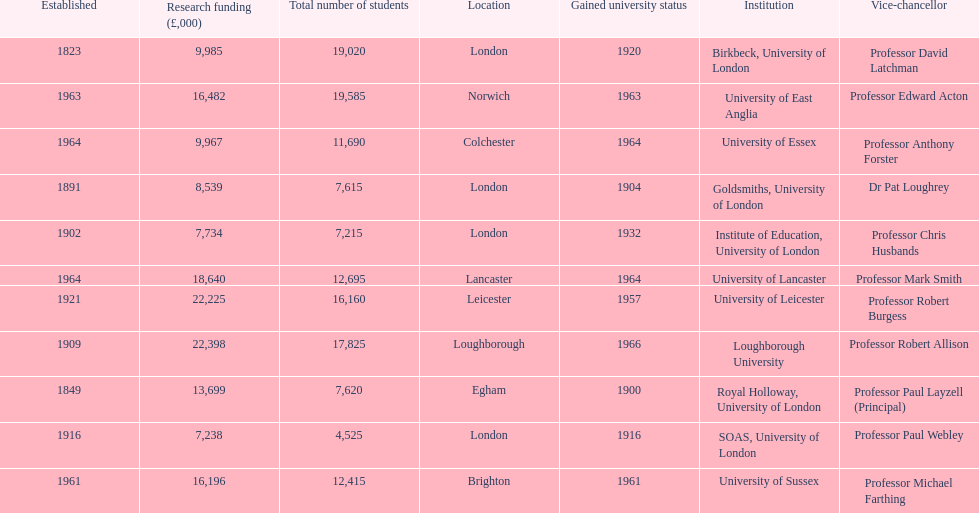Which establishment is granted the largest sum of money for research purposes? Loughborough University. 